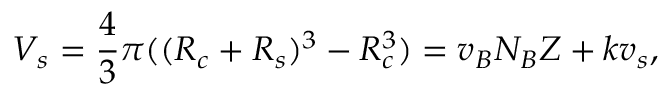<formula> <loc_0><loc_0><loc_500><loc_500>V _ { s } = \frac { 4 } { 3 } \pi ( ( R _ { c } + R _ { s } ) ^ { 3 } - R _ { c } ^ { 3 } ) = v _ { B } N _ { B } Z + k v _ { s } ,</formula> 